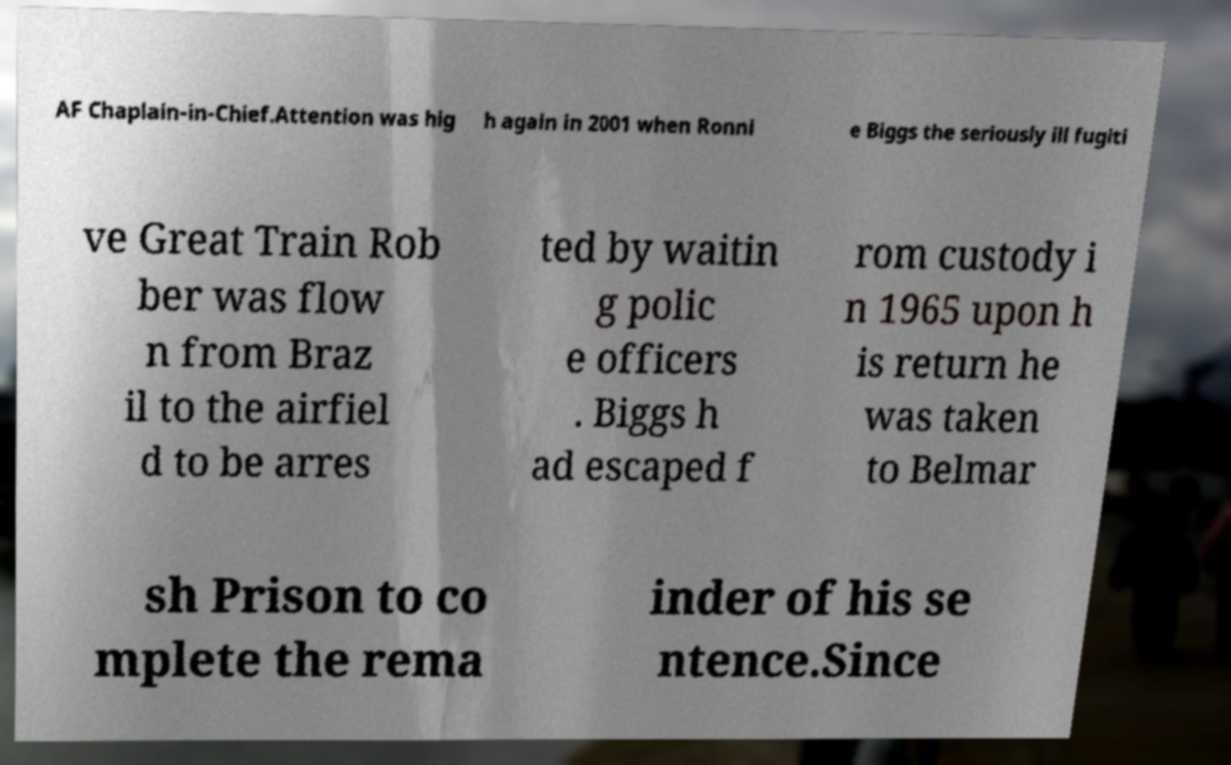Please identify and transcribe the text found in this image. AF Chaplain-in-Chief.Attention was hig h again in 2001 when Ronni e Biggs the seriously ill fugiti ve Great Train Rob ber was flow n from Braz il to the airfiel d to be arres ted by waitin g polic e officers . Biggs h ad escaped f rom custody i n 1965 upon h is return he was taken to Belmar sh Prison to co mplete the rema inder of his se ntence.Since 